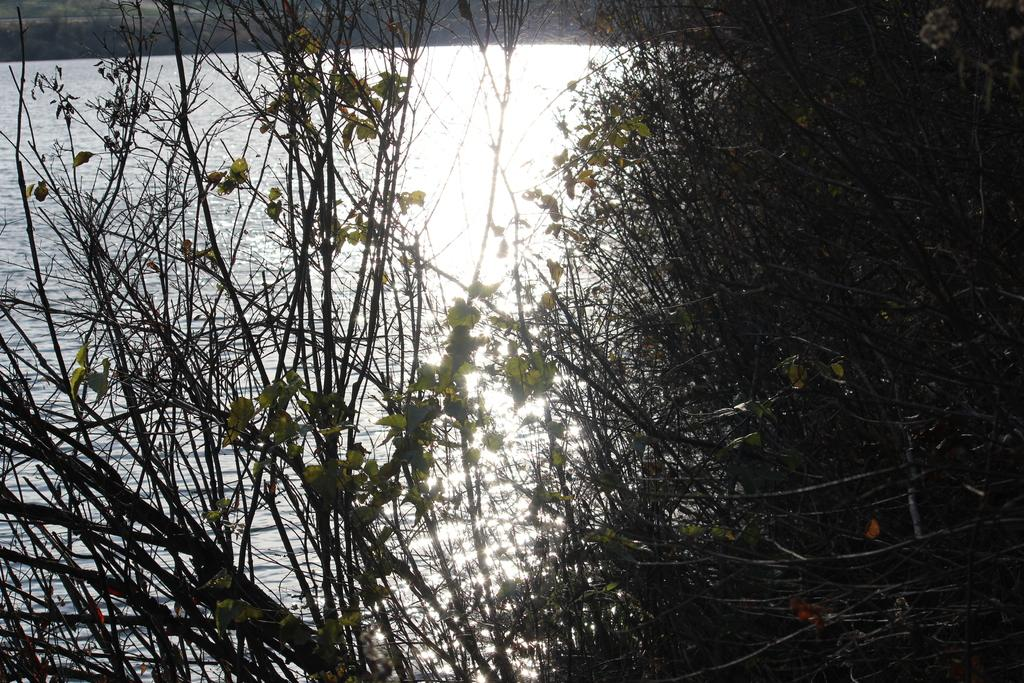What type of living organisms can be seen in the image? Plants can be seen in the image. Where are the plants located in relation to the lake? The plants are in front of a lake. What type of guitar is being played by the person near the lake in the image? There is no person or guitar present in the image; it only features plants in front of a lake. 